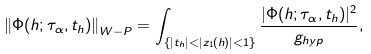<formula> <loc_0><loc_0><loc_500><loc_500>\left \| \Phi ( h ; \tau _ { \alpha } , t _ { h } ) \right \| _ { W - P } = \int _ { \{ | t _ { h } | < | z _ { 1 } ( h ) | < 1 \} } \frac { | \Phi ( h ; \tau _ { \alpha } , t _ { h } ) | ^ { 2 } } { g _ { h y p } } ,</formula> 